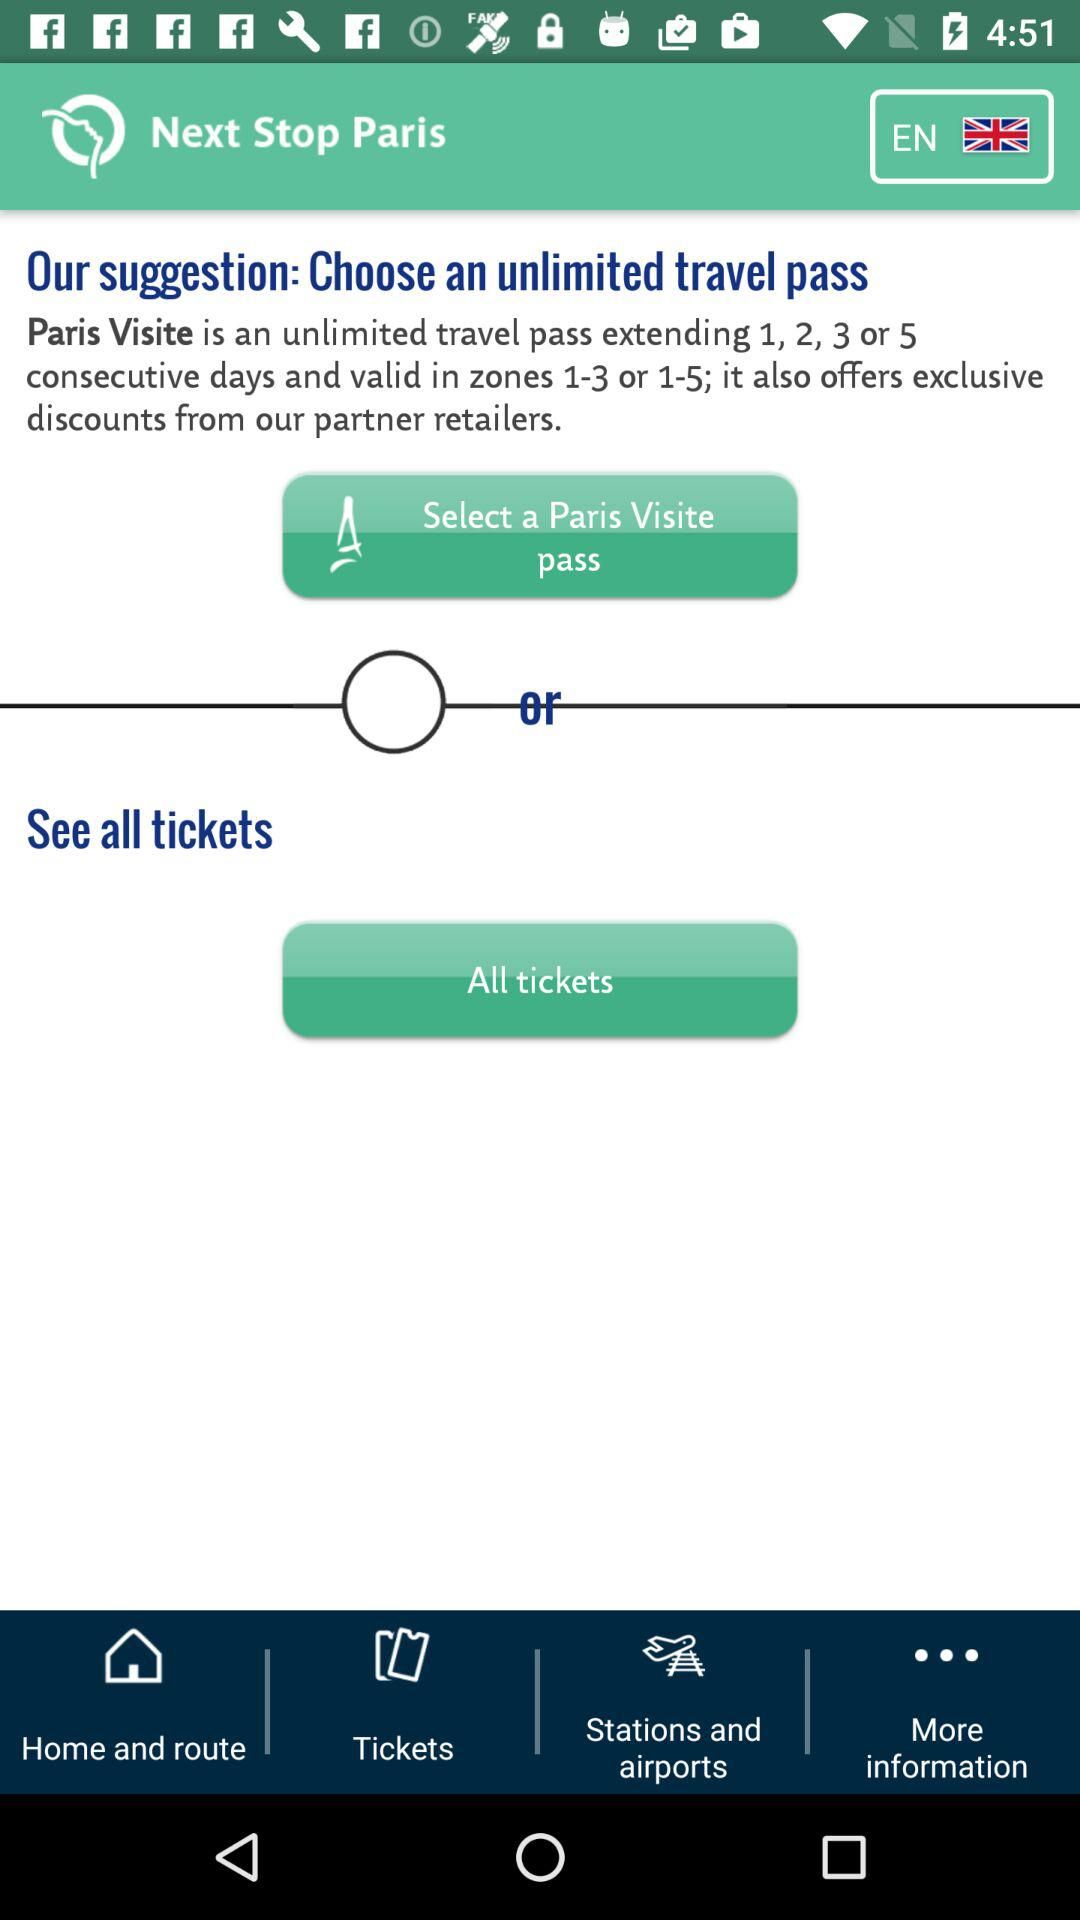What are the zones in which the "Paris Visite" pass is valid? The zones in which the "Paris Visite" pass is valid are 1–3 or 1–5. 